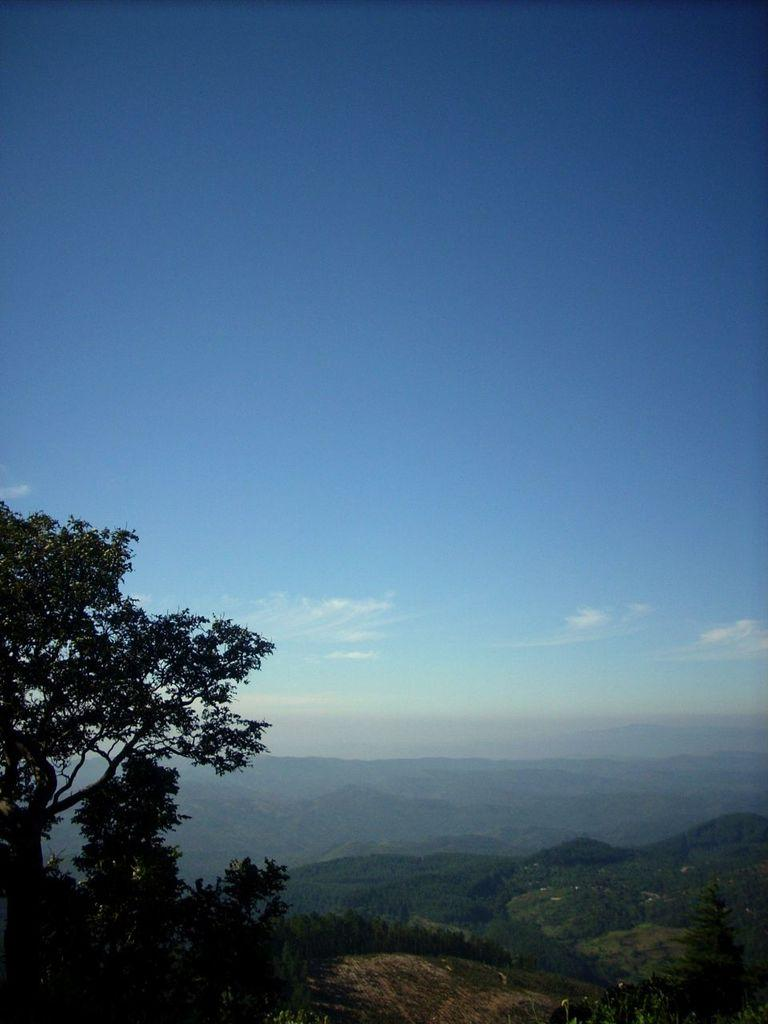What type of natural formation can be seen in the image? There are mountains in the image. What is covering the mountains? The mountains are covered in grass. Where is the tree located in the image? The tree is in the left bottom of the image. What color is the sky in the image? The sky is blue in color. How many pigs are visible in the image? There are no pigs present in the image. What is the mass of the tree in the image? The mass of the tree cannot be determined from the image alone, as it would require additional information and calculations. 